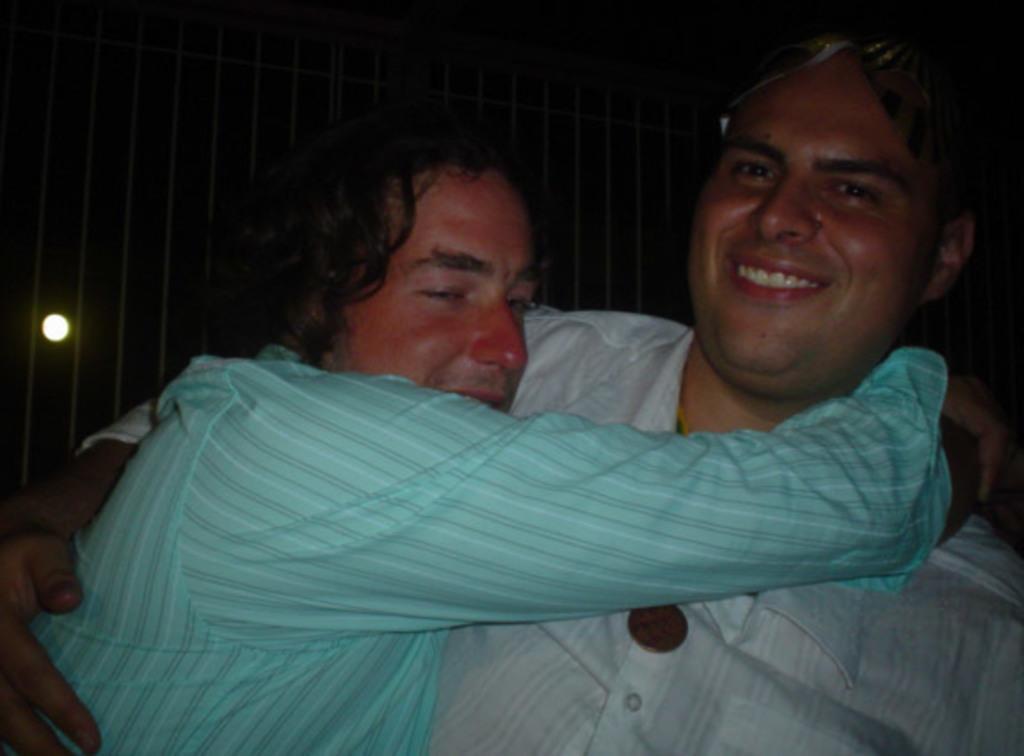Describe this image in one or two sentences. In this picture, we see a man in the white shirt is is hugging the man who is wearing the blue shirt. Both of them are smiling and they might be posing for the photo. In the background, we see a wall and the light. This picture is clicked in the dark. 